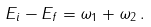Convert formula to latex. <formula><loc_0><loc_0><loc_500><loc_500>E _ { i } - E _ { f } = \omega _ { 1 } + \omega _ { 2 } \, .</formula> 